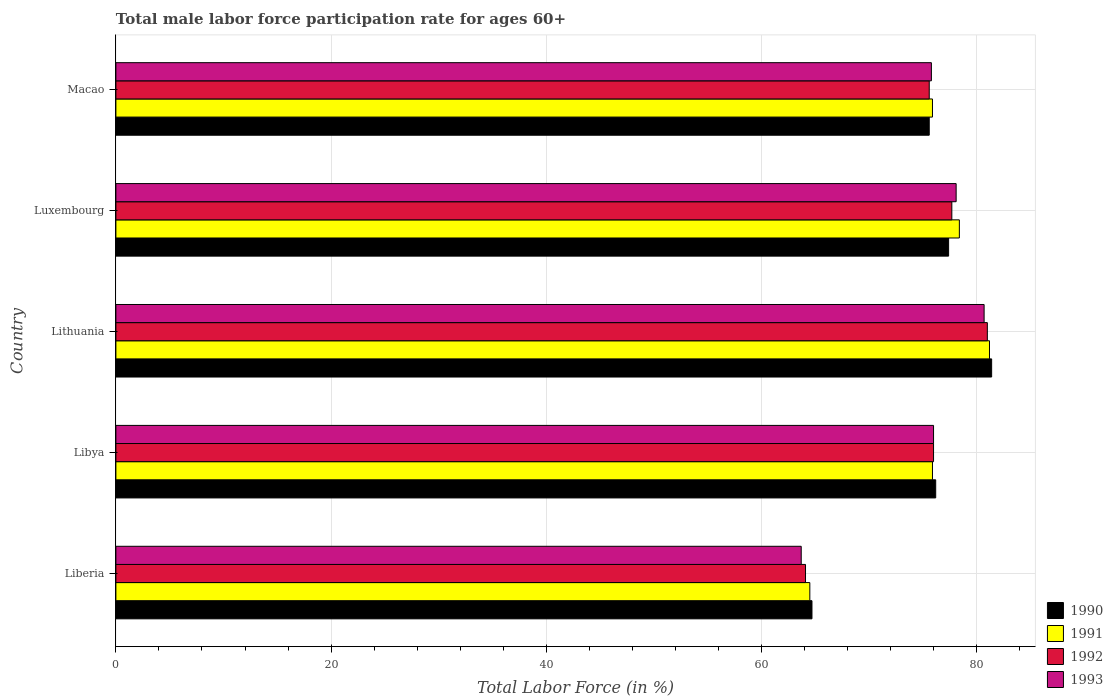How many different coloured bars are there?
Your response must be concise. 4. Are the number of bars on each tick of the Y-axis equal?
Your response must be concise. Yes. How many bars are there on the 4th tick from the top?
Offer a very short reply. 4. How many bars are there on the 2nd tick from the bottom?
Offer a terse response. 4. What is the label of the 3rd group of bars from the top?
Offer a very short reply. Lithuania. In how many cases, is the number of bars for a given country not equal to the number of legend labels?
Keep it short and to the point. 0. What is the male labor force participation rate in 1990 in Macao?
Your response must be concise. 75.6. Across all countries, what is the maximum male labor force participation rate in 1991?
Give a very brief answer. 81.2. Across all countries, what is the minimum male labor force participation rate in 1993?
Your answer should be very brief. 63.7. In which country was the male labor force participation rate in 1990 maximum?
Your answer should be very brief. Lithuania. In which country was the male labor force participation rate in 1993 minimum?
Keep it short and to the point. Liberia. What is the total male labor force participation rate in 1992 in the graph?
Make the answer very short. 374.4. What is the difference between the male labor force participation rate in 1991 in Libya and that in Macao?
Provide a short and direct response. 0. What is the difference between the male labor force participation rate in 1990 in Macao and the male labor force participation rate in 1992 in Lithuania?
Ensure brevity in your answer.  -5.4. What is the average male labor force participation rate in 1990 per country?
Ensure brevity in your answer.  75.06. What is the difference between the male labor force participation rate in 1990 and male labor force participation rate in 1991 in Luxembourg?
Your answer should be very brief. -1. In how many countries, is the male labor force participation rate in 1992 greater than 40 %?
Keep it short and to the point. 5. What is the ratio of the male labor force participation rate in 1993 in Liberia to that in Luxembourg?
Provide a succinct answer. 0.82. Is the difference between the male labor force participation rate in 1990 in Libya and Macao greater than the difference between the male labor force participation rate in 1991 in Libya and Macao?
Keep it short and to the point. Yes. What is the difference between the highest and the lowest male labor force participation rate in 1991?
Ensure brevity in your answer.  16.7. In how many countries, is the male labor force participation rate in 1991 greater than the average male labor force participation rate in 1991 taken over all countries?
Provide a succinct answer. 4. Is the sum of the male labor force participation rate in 1993 in Libya and Macao greater than the maximum male labor force participation rate in 1990 across all countries?
Give a very brief answer. Yes. Is it the case that in every country, the sum of the male labor force participation rate in 1992 and male labor force participation rate in 1990 is greater than the sum of male labor force participation rate in 1993 and male labor force participation rate in 1991?
Keep it short and to the point. No. What does the 1st bar from the top in Luxembourg represents?
Keep it short and to the point. 1993. What does the 3rd bar from the bottom in Lithuania represents?
Keep it short and to the point. 1992. Is it the case that in every country, the sum of the male labor force participation rate in 1991 and male labor force participation rate in 1993 is greater than the male labor force participation rate in 1990?
Your answer should be very brief. Yes. How many bars are there?
Provide a short and direct response. 20. Are all the bars in the graph horizontal?
Keep it short and to the point. Yes. How many countries are there in the graph?
Your response must be concise. 5. What is the difference between two consecutive major ticks on the X-axis?
Keep it short and to the point. 20. Are the values on the major ticks of X-axis written in scientific E-notation?
Provide a short and direct response. No. How are the legend labels stacked?
Offer a terse response. Vertical. What is the title of the graph?
Make the answer very short. Total male labor force participation rate for ages 60+. What is the Total Labor Force (in %) of 1990 in Liberia?
Your answer should be compact. 64.7. What is the Total Labor Force (in %) of 1991 in Liberia?
Provide a short and direct response. 64.5. What is the Total Labor Force (in %) in 1992 in Liberia?
Make the answer very short. 64.1. What is the Total Labor Force (in %) in 1993 in Liberia?
Provide a succinct answer. 63.7. What is the Total Labor Force (in %) of 1990 in Libya?
Make the answer very short. 76.2. What is the Total Labor Force (in %) in 1991 in Libya?
Your answer should be compact. 75.9. What is the Total Labor Force (in %) of 1990 in Lithuania?
Provide a succinct answer. 81.4. What is the Total Labor Force (in %) of 1991 in Lithuania?
Keep it short and to the point. 81.2. What is the Total Labor Force (in %) of 1993 in Lithuania?
Your answer should be very brief. 80.7. What is the Total Labor Force (in %) in 1990 in Luxembourg?
Your answer should be very brief. 77.4. What is the Total Labor Force (in %) in 1991 in Luxembourg?
Provide a succinct answer. 78.4. What is the Total Labor Force (in %) of 1992 in Luxembourg?
Offer a terse response. 77.7. What is the Total Labor Force (in %) of 1993 in Luxembourg?
Offer a terse response. 78.1. What is the Total Labor Force (in %) in 1990 in Macao?
Give a very brief answer. 75.6. What is the Total Labor Force (in %) in 1991 in Macao?
Your answer should be compact. 75.9. What is the Total Labor Force (in %) of 1992 in Macao?
Provide a succinct answer. 75.6. What is the Total Labor Force (in %) of 1993 in Macao?
Your answer should be very brief. 75.8. Across all countries, what is the maximum Total Labor Force (in %) of 1990?
Give a very brief answer. 81.4. Across all countries, what is the maximum Total Labor Force (in %) in 1991?
Make the answer very short. 81.2. Across all countries, what is the maximum Total Labor Force (in %) in 1992?
Provide a short and direct response. 81. Across all countries, what is the maximum Total Labor Force (in %) in 1993?
Provide a short and direct response. 80.7. Across all countries, what is the minimum Total Labor Force (in %) of 1990?
Provide a short and direct response. 64.7. Across all countries, what is the minimum Total Labor Force (in %) in 1991?
Make the answer very short. 64.5. Across all countries, what is the minimum Total Labor Force (in %) of 1992?
Offer a terse response. 64.1. Across all countries, what is the minimum Total Labor Force (in %) of 1993?
Provide a short and direct response. 63.7. What is the total Total Labor Force (in %) in 1990 in the graph?
Provide a short and direct response. 375.3. What is the total Total Labor Force (in %) of 1991 in the graph?
Offer a terse response. 375.9. What is the total Total Labor Force (in %) of 1992 in the graph?
Offer a terse response. 374.4. What is the total Total Labor Force (in %) of 1993 in the graph?
Offer a very short reply. 374.3. What is the difference between the Total Labor Force (in %) of 1990 in Liberia and that in Libya?
Offer a terse response. -11.5. What is the difference between the Total Labor Force (in %) of 1993 in Liberia and that in Libya?
Provide a succinct answer. -12.3. What is the difference between the Total Labor Force (in %) of 1990 in Liberia and that in Lithuania?
Provide a succinct answer. -16.7. What is the difference between the Total Labor Force (in %) in 1991 in Liberia and that in Lithuania?
Give a very brief answer. -16.7. What is the difference between the Total Labor Force (in %) of 1992 in Liberia and that in Lithuania?
Ensure brevity in your answer.  -16.9. What is the difference between the Total Labor Force (in %) of 1993 in Liberia and that in Luxembourg?
Provide a succinct answer. -14.4. What is the difference between the Total Labor Force (in %) in 1990 in Liberia and that in Macao?
Make the answer very short. -10.9. What is the difference between the Total Labor Force (in %) of 1991 in Liberia and that in Macao?
Offer a terse response. -11.4. What is the difference between the Total Labor Force (in %) of 1992 in Liberia and that in Macao?
Offer a very short reply. -11.5. What is the difference between the Total Labor Force (in %) of 1993 in Liberia and that in Macao?
Keep it short and to the point. -12.1. What is the difference between the Total Labor Force (in %) of 1991 in Libya and that in Lithuania?
Provide a succinct answer. -5.3. What is the difference between the Total Labor Force (in %) of 1991 in Libya and that in Luxembourg?
Provide a short and direct response. -2.5. What is the difference between the Total Labor Force (in %) of 1993 in Libya and that in Luxembourg?
Your answer should be very brief. -2.1. What is the difference between the Total Labor Force (in %) in 1991 in Libya and that in Macao?
Your answer should be very brief. 0. What is the difference between the Total Labor Force (in %) in 1990 in Lithuania and that in Macao?
Provide a short and direct response. 5.8. What is the difference between the Total Labor Force (in %) of 1992 in Lithuania and that in Macao?
Your answer should be compact. 5.4. What is the difference between the Total Labor Force (in %) of 1990 in Luxembourg and that in Macao?
Make the answer very short. 1.8. What is the difference between the Total Labor Force (in %) of 1992 in Luxembourg and that in Macao?
Make the answer very short. 2.1. What is the difference between the Total Labor Force (in %) of 1990 in Liberia and the Total Labor Force (in %) of 1991 in Libya?
Give a very brief answer. -11.2. What is the difference between the Total Labor Force (in %) in 1990 in Liberia and the Total Labor Force (in %) in 1992 in Libya?
Your answer should be compact. -11.3. What is the difference between the Total Labor Force (in %) in 1990 in Liberia and the Total Labor Force (in %) in 1993 in Libya?
Give a very brief answer. -11.3. What is the difference between the Total Labor Force (in %) of 1991 in Liberia and the Total Labor Force (in %) of 1992 in Libya?
Your answer should be very brief. -11.5. What is the difference between the Total Labor Force (in %) in 1990 in Liberia and the Total Labor Force (in %) in 1991 in Lithuania?
Keep it short and to the point. -16.5. What is the difference between the Total Labor Force (in %) of 1990 in Liberia and the Total Labor Force (in %) of 1992 in Lithuania?
Offer a very short reply. -16.3. What is the difference between the Total Labor Force (in %) in 1991 in Liberia and the Total Labor Force (in %) in 1992 in Lithuania?
Your response must be concise. -16.5. What is the difference between the Total Labor Force (in %) in 1991 in Liberia and the Total Labor Force (in %) in 1993 in Lithuania?
Keep it short and to the point. -16.2. What is the difference between the Total Labor Force (in %) in 1992 in Liberia and the Total Labor Force (in %) in 1993 in Lithuania?
Your answer should be compact. -16.6. What is the difference between the Total Labor Force (in %) in 1990 in Liberia and the Total Labor Force (in %) in 1991 in Luxembourg?
Offer a very short reply. -13.7. What is the difference between the Total Labor Force (in %) of 1990 in Liberia and the Total Labor Force (in %) of 1993 in Luxembourg?
Offer a terse response. -13.4. What is the difference between the Total Labor Force (in %) of 1991 in Liberia and the Total Labor Force (in %) of 1992 in Luxembourg?
Give a very brief answer. -13.2. What is the difference between the Total Labor Force (in %) in 1990 in Liberia and the Total Labor Force (in %) in 1993 in Macao?
Offer a very short reply. -11.1. What is the difference between the Total Labor Force (in %) in 1991 in Liberia and the Total Labor Force (in %) in 1993 in Macao?
Your answer should be compact. -11.3. What is the difference between the Total Labor Force (in %) in 1992 in Liberia and the Total Labor Force (in %) in 1993 in Macao?
Provide a succinct answer. -11.7. What is the difference between the Total Labor Force (in %) in 1990 in Libya and the Total Labor Force (in %) in 1991 in Lithuania?
Your answer should be very brief. -5. What is the difference between the Total Labor Force (in %) of 1990 in Libya and the Total Labor Force (in %) of 1993 in Lithuania?
Provide a short and direct response. -4.5. What is the difference between the Total Labor Force (in %) in 1990 in Libya and the Total Labor Force (in %) in 1991 in Luxembourg?
Make the answer very short. -2.2. What is the difference between the Total Labor Force (in %) of 1990 in Libya and the Total Labor Force (in %) of 1992 in Luxembourg?
Give a very brief answer. -1.5. What is the difference between the Total Labor Force (in %) of 1990 in Libya and the Total Labor Force (in %) of 1993 in Luxembourg?
Offer a terse response. -1.9. What is the difference between the Total Labor Force (in %) of 1991 in Libya and the Total Labor Force (in %) of 1992 in Luxembourg?
Offer a very short reply. -1.8. What is the difference between the Total Labor Force (in %) of 1991 in Libya and the Total Labor Force (in %) of 1993 in Luxembourg?
Offer a very short reply. -2.2. What is the difference between the Total Labor Force (in %) in 1990 in Libya and the Total Labor Force (in %) in 1992 in Macao?
Provide a succinct answer. 0.6. What is the difference between the Total Labor Force (in %) in 1990 in Libya and the Total Labor Force (in %) in 1993 in Macao?
Ensure brevity in your answer.  0.4. What is the difference between the Total Labor Force (in %) of 1991 in Libya and the Total Labor Force (in %) of 1992 in Macao?
Offer a terse response. 0.3. What is the difference between the Total Labor Force (in %) in 1990 in Lithuania and the Total Labor Force (in %) in 1991 in Luxembourg?
Your response must be concise. 3. What is the difference between the Total Labor Force (in %) in 1990 in Lithuania and the Total Labor Force (in %) in 1992 in Luxembourg?
Ensure brevity in your answer.  3.7. What is the difference between the Total Labor Force (in %) of 1990 in Lithuania and the Total Labor Force (in %) of 1993 in Luxembourg?
Your answer should be very brief. 3.3. What is the difference between the Total Labor Force (in %) of 1991 in Lithuania and the Total Labor Force (in %) of 1993 in Luxembourg?
Provide a short and direct response. 3.1. What is the difference between the Total Labor Force (in %) in 1992 in Lithuania and the Total Labor Force (in %) in 1993 in Luxembourg?
Keep it short and to the point. 2.9. What is the difference between the Total Labor Force (in %) of 1990 in Lithuania and the Total Labor Force (in %) of 1991 in Macao?
Give a very brief answer. 5.5. What is the difference between the Total Labor Force (in %) of 1991 in Lithuania and the Total Labor Force (in %) of 1992 in Macao?
Your response must be concise. 5.6. What is the difference between the Total Labor Force (in %) in 1991 in Lithuania and the Total Labor Force (in %) in 1993 in Macao?
Give a very brief answer. 5.4. What is the difference between the Total Labor Force (in %) of 1992 in Lithuania and the Total Labor Force (in %) of 1993 in Macao?
Your answer should be compact. 5.2. What is the difference between the Total Labor Force (in %) of 1991 in Luxembourg and the Total Labor Force (in %) of 1992 in Macao?
Your answer should be compact. 2.8. What is the difference between the Total Labor Force (in %) of 1992 in Luxembourg and the Total Labor Force (in %) of 1993 in Macao?
Make the answer very short. 1.9. What is the average Total Labor Force (in %) of 1990 per country?
Give a very brief answer. 75.06. What is the average Total Labor Force (in %) in 1991 per country?
Your answer should be very brief. 75.18. What is the average Total Labor Force (in %) in 1992 per country?
Give a very brief answer. 74.88. What is the average Total Labor Force (in %) in 1993 per country?
Provide a succinct answer. 74.86. What is the difference between the Total Labor Force (in %) in 1990 and Total Labor Force (in %) in 1991 in Liberia?
Offer a very short reply. 0.2. What is the difference between the Total Labor Force (in %) in 1990 and Total Labor Force (in %) in 1993 in Liberia?
Offer a terse response. 1. What is the difference between the Total Labor Force (in %) of 1991 and Total Labor Force (in %) of 1993 in Liberia?
Your answer should be very brief. 0.8. What is the difference between the Total Labor Force (in %) of 1990 and Total Labor Force (in %) of 1991 in Libya?
Keep it short and to the point. 0.3. What is the difference between the Total Labor Force (in %) in 1990 and Total Labor Force (in %) in 1992 in Libya?
Keep it short and to the point. 0.2. What is the difference between the Total Labor Force (in %) of 1991 and Total Labor Force (in %) of 1992 in Libya?
Provide a succinct answer. -0.1. What is the difference between the Total Labor Force (in %) in 1991 and Total Labor Force (in %) in 1993 in Libya?
Keep it short and to the point. -0.1. What is the difference between the Total Labor Force (in %) of 1992 and Total Labor Force (in %) of 1993 in Libya?
Provide a short and direct response. 0. What is the difference between the Total Labor Force (in %) of 1990 and Total Labor Force (in %) of 1992 in Lithuania?
Make the answer very short. 0.4. What is the difference between the Total Labor Force (in %) in 1991 and Total Labor Force (in %) in 1993 in Lithuania?
Provide a short and direct response. 0.5. What is the difference between the Total Labor Force (in %) of 1992 and Total Labor Force (in %) of 1993 in Lithuania?
Your response must be concise. 0.3. What is the difference between the Total Labor Force (in %) of 1990 and Total Labor Force (in %) of 1991 in Luxembourg?
Your answer should be very brief. -1. What is the difference between the Total Labor Force (in %) of 1990 and Total Labor Force (in %) of 1992 in Luxembourg?
Offer a terse response. -0.3. What is the difference between the Total Labor Force (in %) of 1990 and Total Labor Force (in %) of 1993 in Luxembourg?
Your response must be concise. -0.7. What is the difference between the Total Labor Force (in %) of 1991 and Total Labor Force (in %) of 1993 in Luxembourg?
Your answer should be very brief. 0.3. What is the difference between the Total Labor Force (in %) in 1990 and Total Labor Force (in %) in 1991 in Macao?
Your answer should be compact. -0.3. What is the difference between the Total Labor Force (in %) of 1990 and Total Labor Force (in %) of 1992 in Macao?
Your answer should be very brief. 0. What is the difference between the Total Labor Force (in %) of 1990 and Total Labor Force (in %) of 1993 in Macao?
Give a very brief answer. -0.2. What is the difference between the Total Labor Force (in %) in 1991 and Total Labor Force (in %) in 1992 in Macao?
Your answer should be very brief. 0.3. What is the difference between the Total Labor Force (in %) of 1991 and Total Labor Force (in %) of 1993 in Macao?
Your response must be concise. 0.1. What is the difference between the Total Labor Force (in %) of 1992 and Total Labor Force (in %) of 1993 in Macao?
Your answer should be compact. -0.2. What is the ratio of the Total Labor Force (in %) in 1990 in Liberia to that in Libya?
Ensure brevity in your answer.  0.85. What is the ratio of the Total Labor Force (in %) in 1991 in Liberia to that in Libya?
Your answer should be very brief. 0.85. What is the ratio of the Total Labor Force (in %) in 1992 in Liberia to that in Libya?
Provide a short and direct response. 0.84. What is the ratio of the Total Labor Force (in %) of 1993 in Liberia to that in Libya?
Your answer should be very brief. 0.84. What is the ratio of the Total Labor Force (in %) of 1990 in Liberia to that in Lithuania?
Offer a terse response. 0.79. What is the ratio of the Total Labor Force (in %) in 1991 in Liberia to that in Lithuania?
Offer a very short reply. 0.79. What is the ratio of the Total Labor Force (in %) in 1992 in Liberia to that in Lithuania?
Offer a very short reply. 0.79. What is the ratio of the Total Labor Force (in %) of 1993 in Liberia to that in Lithuania?
Make the answer very short. 0.79. What is the ratio of the Total Labor Force (in %) in 1990 in Liberia to that in Luxembourg?
Your answer should be compact. 0.84. What is the ratio of the Total Labor Force (in %) in 1991 in Liberia to that in Luxembourg?
Give a very brief answer. 0.82. What is the ratio of the Total Labor Force (in %) in 1992 in Liberia to that in Luxembourg?
Offer a terse response. 0.82. What is the ratio of the Total Labor Force (in %) in 1993 in Liberia to that in Luxembourg?
Ensure brevity in your answer.  0.82. What is the ratio of the Total Labor Force (in %) of 1990 in Liberia to that in Macao?
Offer a terse response. 0.86. What is the ratio of the Total Labor Force (in %) in 1991 in Liberia to that in Macao?
Give a very brief answer. 0.85. What is the ratio of the Total Labor Force (in %) of 1992 in Liberia to that in Macao?
Your answer should be compact. 0.85. What is the ratio of the Total Labor Force (in %) in 1993 in Liberia to that in Macao?
Ensure brevity in your answer.  0.84. What is the ratio of the Total Labor Force (in %) in 1990 in Libya to that in Lithuania?
Give a very brief answer. 0.94. What is the ratio of the Total Labor Force (in %) of 1991 in Libya to that in Lithuania?
Make the answer very short. 0.93. What is the ratio of the Total Labor Force (in %) of 1992 in Libya to that in Lithuania?
Your answer should be very brief. 0.94. What is the ratio of the Total Labor Force (in %) of 1993 in Libya to that in Lithuania?
Your answer should be very brief. 0.94. What is the ratio of the Total Labor Force (in %) in 1990 in Libya to that in Luxembourg?
Keep it short and to the point. 0.98. What is the ratio of the Total Labor Force (in %) in 1991 in Libya to that in Luxembourg?
Keep it short and to the point. 0.97. What is the ratio of the Total Labor Force (in %) of 1992 in Libya to that in Luxembourg?
Ensure brevity in your answer.  0.98. What is the ratio of the Total Labor Force (in %) in 1993 in Libya to that in Luxembourg?
Provide a short and direct response. 0.97. What is the ratio of the Total Labor Force (in %) in 1990 in Libya to that in Macao?
Provide a short and direct response. 1.01. What is the ratio of the Total Labor Force (in %) of 1991 in Libya to that in Macao?
Offer a terse response. 1. What is the ratio of the Total Labor Force (in %) of 1990 in Lithuania to that in Luxembourg?
Keep it short and to the point. 1.05. What is the ratio of the Total Labor Force (in %) in 1991 in Lithuania to that in Luxembourg?
Offer a very short reply. 1.04. What is the ratio of the Total Labor Force (in %) in 1992 in Lithuania to that in Luxembourg?
Give a very brief answer. 1.04. What is the ratio of the Total Labor Force (in %) of 1990 in Lithuania to that in Macao?
Your response must be concise. 1.08. What is the ratio of the Total Labor Force (in %) in 1991 in Lithuania to that in Macao?
Your answer should be compact. 1.07. What is the ratio of the Total Labor Force (in %) of 1992 in Lithuania to that in Macao?
Ensure brevity in your answer.  1.07. What is the ratio of the Total Labor Force (in %) of 1993 in Lithuania to that in Macao?
Make the answer very short. 1.06. What is the ratio of the Total Labor Force (in %) in 1990 in Luxembourg to that in Macao?
Provide a short and direct response. 1.02. What is the ratio of the Total Labor Force (in %) of 1991 in Luxembourg to that in Macao?
Provide a short and direct response. 1.03. What is the ratio of the Total Labor Force (in %) in 1992 in Luxembourg to that in Macao?
Provide a short and direct response. 1.03. What is the ratio of the Total Labor Force (in %) in 1993 in Luxembourg to that in Macao?
Offer a terse response. 1.03. What is the difference between the highest and the second highest Total Labor Force (in %) in 1991?
Make the answer very short. 2.8. What is the difference between the highest and the second highest Total Labor Force (in %) of 1992?
Provide a short and direct response. 3.3. What is the difference between the highest and the second highest Total Labor Force (in %) of 1993?
Provide a succinct answer. 2.6. What is the difference between the highest and the lowest Total Labor Force (in %) in 1991?
Give a very brief answer. 16.7. What is the difference between the highest and the lowest Total Labor Force (in %) in 1993?
Your response must be concise. 17. 